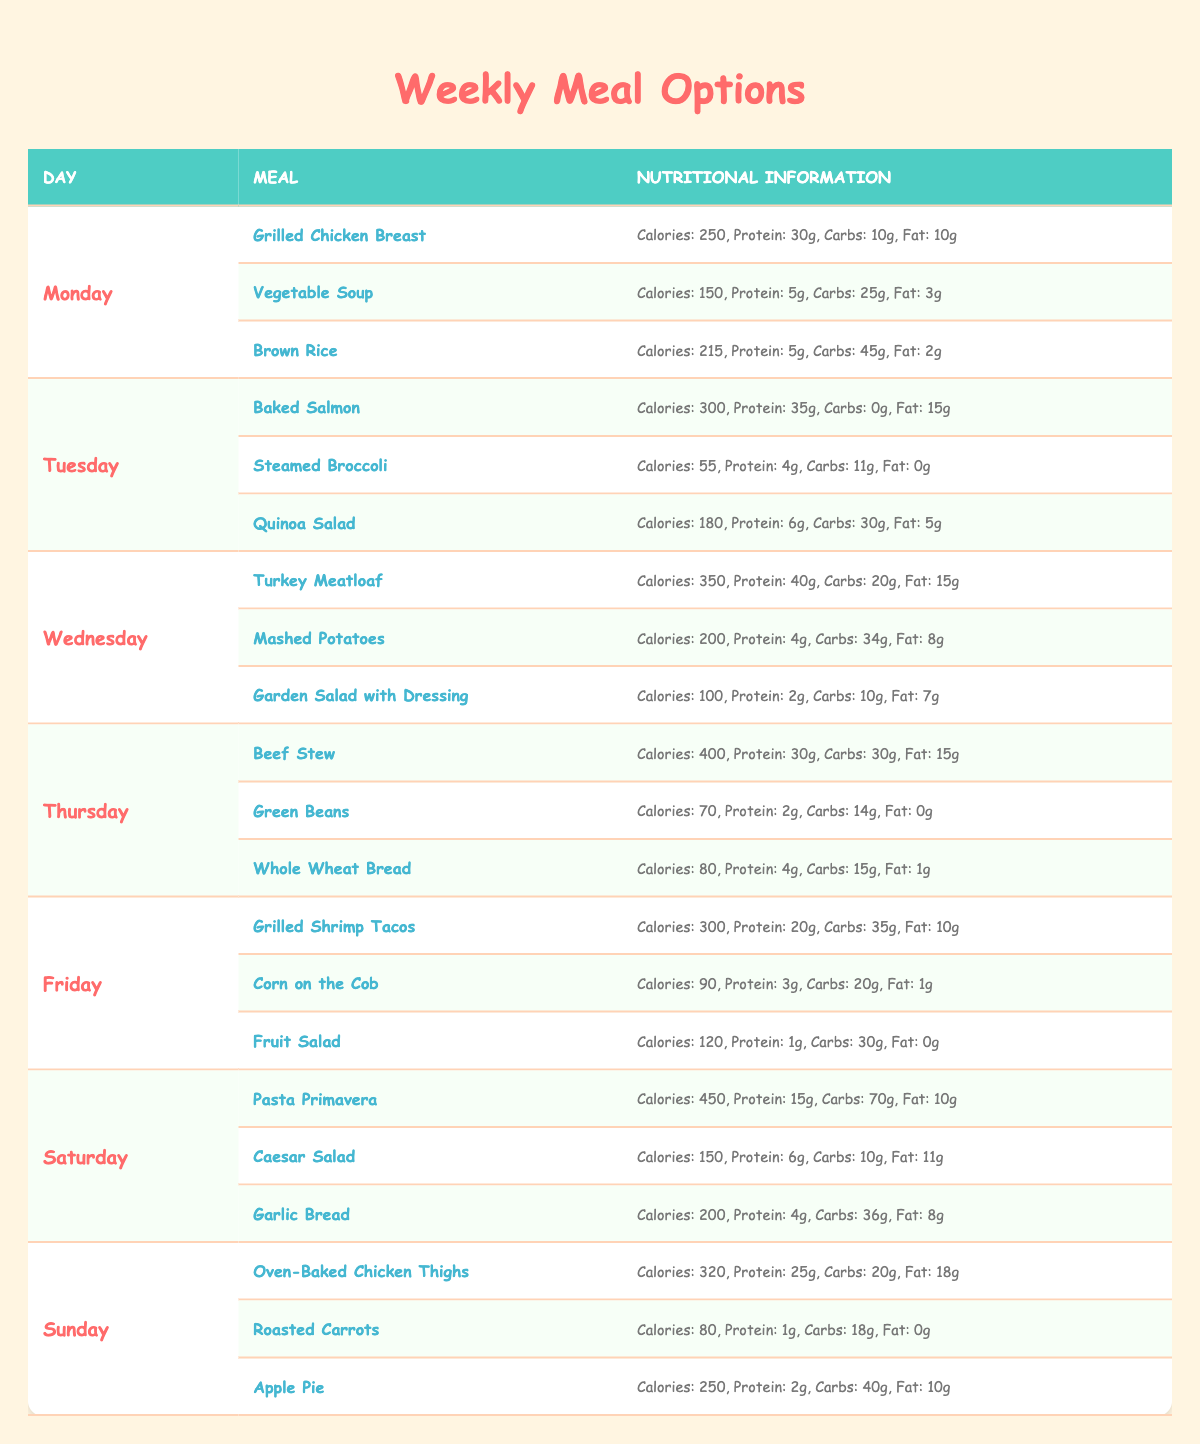What meal has the highest calorie count on Friday? On Friday, the meals are Grilled Shrimp Tacos (300 calories), Corn on the Cob (90 calories), and Fruit Salad (120 calories). The Grilled Shrimp Tacos has the highest calorie count of 300.
Answer: 300 Which day has the lowest total calories for its meals? To find the day with the lowest total calories, we sum the calories for each day: Monday (615), Tuesday (535), Wednesday (650), Thursday (550), Friday (510), Saturday (800), and Sunday (650). Friday has the lowest total at 510 calories.
Answer: Friday Is there any meal on Sunday that contains more than 20 grams of protein? The meals on Sunday are Oven-Baked Chicken Thighs (25g), Roasted Carrots (1g), and Apple Pie (2g). The Oven-Baked Chicken Thighs has more than 20 grams of protein, confirming that yes, there is a meal that meets this criterion.
Answer: Yes What is the average number of carbohydrates for all meals on Thursday? On Thursday, the meals are Beef Stew (30g), Green Beans (14g), and Whole Wheat Bread (15g). Combine the carbohydrates: 30 + 14 + 15 = 59 grams. To find the average: 59g / 3 meals = 19.67 grams.
Answer: 19.67 Which meal on Saturday has the highest fat content? The meals on Saturday are Pasta Primavera (10g), Caesar Salad (11g), and Garlic Bread (8g). Among these, the Caesar Salad has the highest fat content of 11 grams.
Answer: 11 What is the total protein content for all meals on Monday? On Monday, we have Grilled Chicken Breast (30g), Vegetable Soup (5g), and Brown Rice (5g). The total protein is 30 + 5 + 5 = 40 grams for all meals combined on Monday.
Answer: 40 Are there more meals with vegetables than meat on Tuesday? On Tuesday, the meals are Baked Salmon (meat), Steamed Broccoli (vegetable), and Quinoa Salad (vegetable). There are 2 vegetable meals and 1 meat meal on Tuesday. Therefore, yes, there are more vegetable meals than meat meals.
Answer: Yes Which day has a meal with the least amount of carbohydrates? The meals' carbohydrate counts for each day can be compared. Vegetable Soup on Monday has 25g, Steamed Broccoli on Tuesday has 11g, Mashed Potatoes on Wednesday has 34g, Green Beans on Thursday has 14g, Corn on the Cob on Friday has 20g, Caesar Salad on Saturday has 10g, and Roasted Carrots on Sunday has 18g. Steamed Broccoli has the least at 11 grams.
Answer: Tuesday 